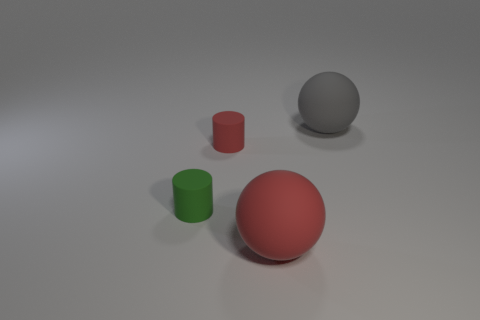Add 3 small green cylinders. How many objects exist? 7 Subtract 0 red cubes. How many objects are left? 4 Subtract all small cylinders. Subtract all red matte things. How many objects are left? 0 Add 1 red rubber objects. How many red rubber objects are left? 3 Add 1 large blocks. How many large blocks exist? 1 